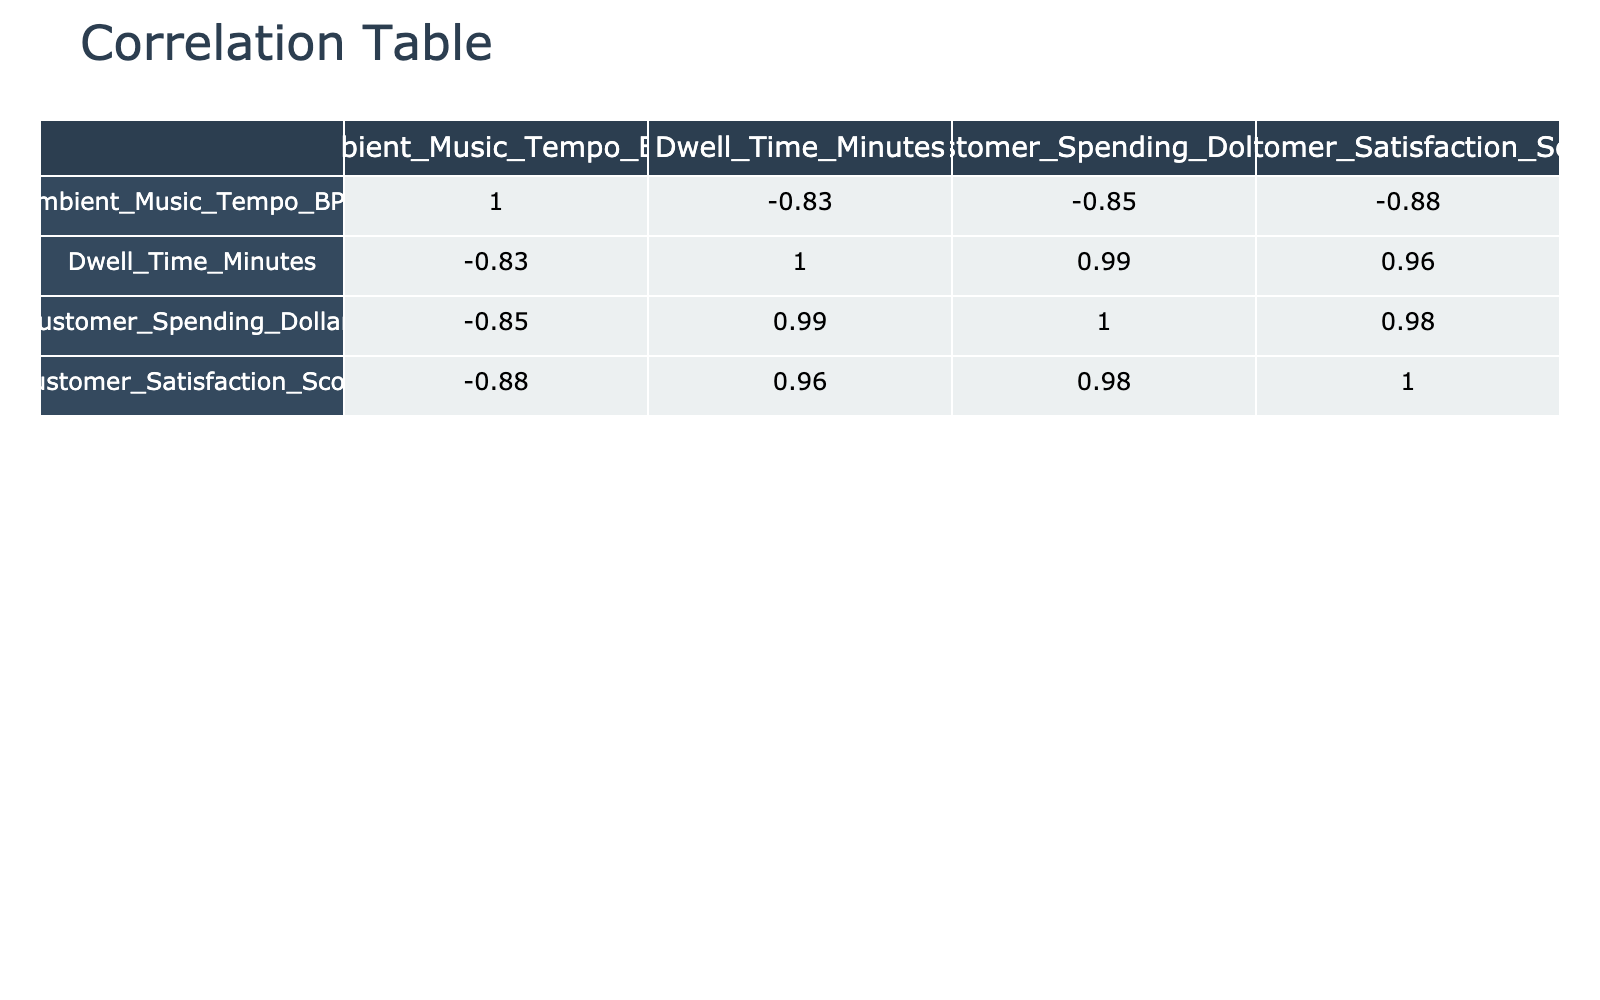What is the correlation coefficient between ambient music tempo and customer spending? In the correlation table, I look for the correlation coefficient in the row labeled 'Ambient_Music_Tempo_BPM' and the column labeled 'Customer_Spending_Dollars'. I find the correlation coefficient is 0.87.
Answer: 0.87 What is the dwell time when the ambient music tempo is 80 BPM? I look under the 'Ambient_Music_Tempo_BPM' column for the value 80, then check the corresponding 'Dwell_Time_Minutes' value. It shows a dwell time of 28 minutes.
Answer: 28 Is the average customer satisfaction score greater than 4.5? I calculate the average customer satisfaction score by adding all the scores (4.5 + 4.7 + 4.6 + 4.8 + 4.4 + 4.1 + 3.9 + 4.2 + 3.8 + 3.5 = 45.5) and dividing by the number of scores (10). Thus, the average is 45.5/10 = 4.55, which is greater than 4.5.
Answer: Yes What is the difference in customer spending between the highest and lowest values? I identify the highest and lowest customer spending from the table. The maximum spending is 20.00, and the minimum is 8.00. I calculate the difference by subtracting the lowest from the highest (20.00 - 8.00 = 12.00).
Answer: 12.00 What is the relationship between customer satisfaction score and dwell time at 120 BPM? Looking at the table for 120 BPM, I find the corresponding 'Customer_Satisfaction_Score' as 3.9 and 'Dwell_Time_Minutes' as 15. I infer that as the dwell time decreases to 15 minutes, the satisfaction score decreases to 3.9, indicating a potential negative correlation at this point.
Answer: Negative correlation 